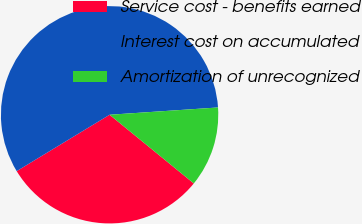Convert chart to OTSL. <chart><loc_0><loc_0><loc_500><loc_500><pie_chart><fcel>Service cost - benefits earned<fcel>Interest cost on accumulated<fcel>Amortization of unrecognized<nl><fcel>30.43%<fcel>57.61%<fcel>11.96%<nl></chart> 